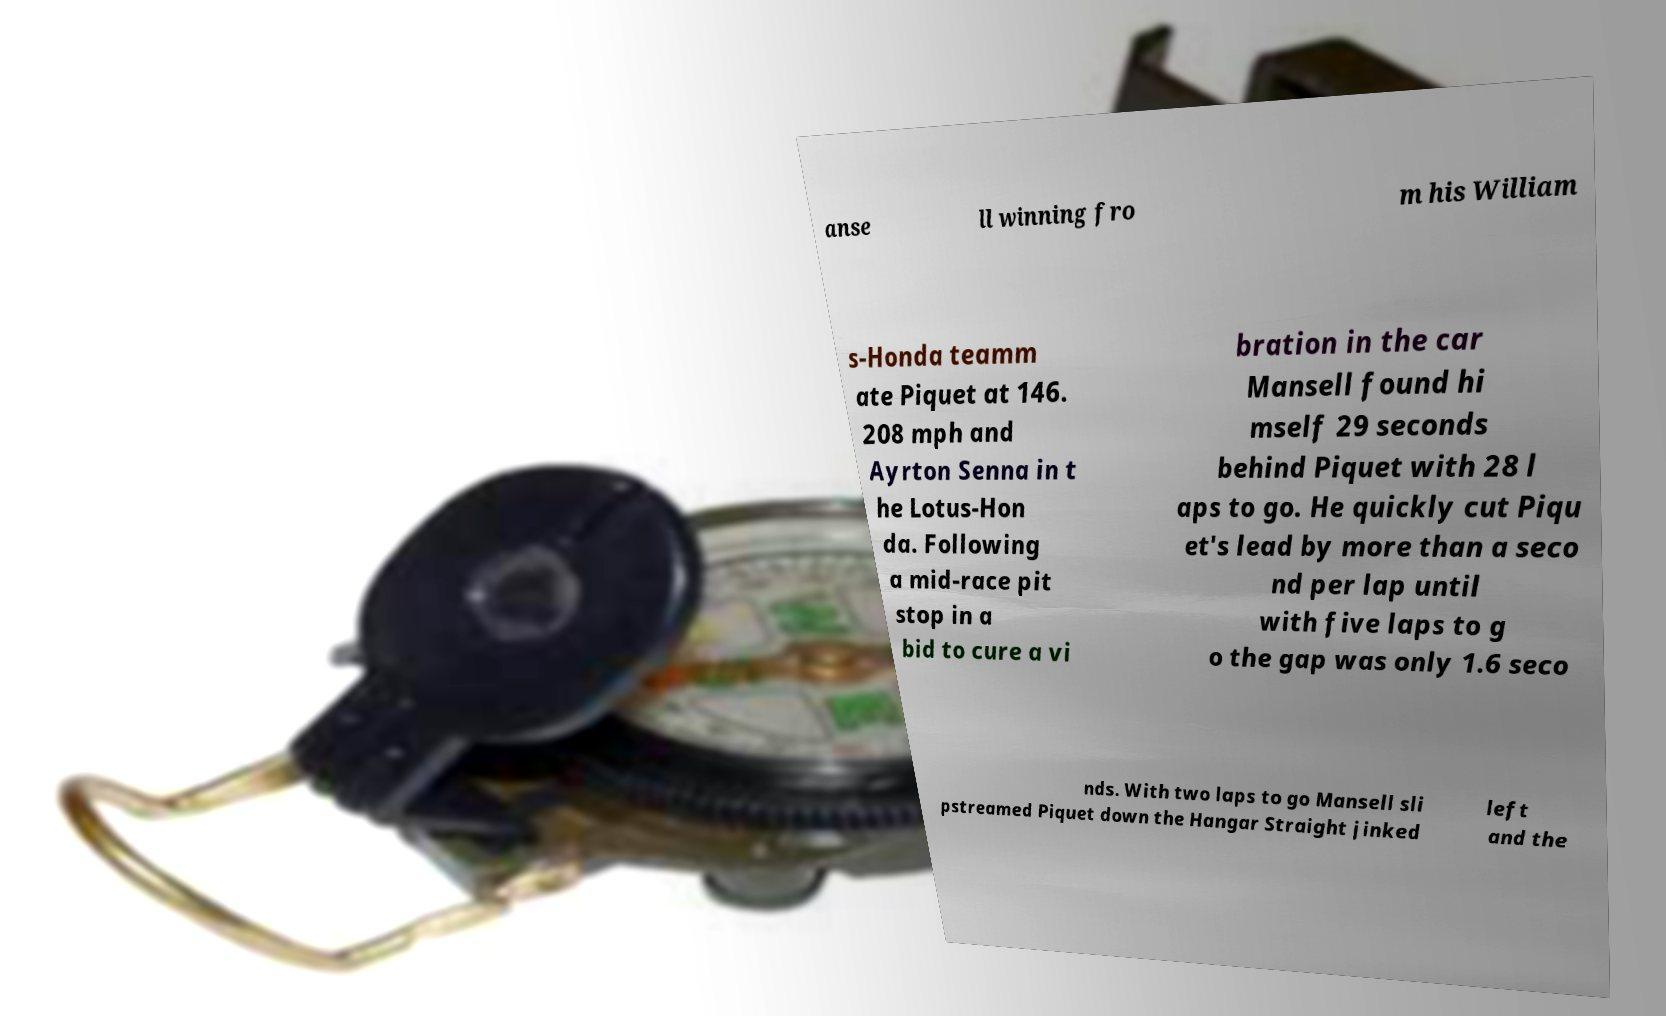For documentation purposes, I need the text within this image transcribed. Could you provide that? anse ll winning fro m his William s-Honda teamm ate Piquet at 146. 208 mph and Ayrton Senna in t he Lotus-Hon da. Following a mid-race pit stop in a bid to cure a vi bration in the car Mansell found hi mself 29 seconds behind Piquet with 28 l aps to go. He quickly cut Piqu et's lead by more than a seco nd per lap until with five laps to g o the gap was only 1.6 seco nds. With two laps to go Mansell sli pstreamed Piquet down the Hangar Straight jinked left and the 